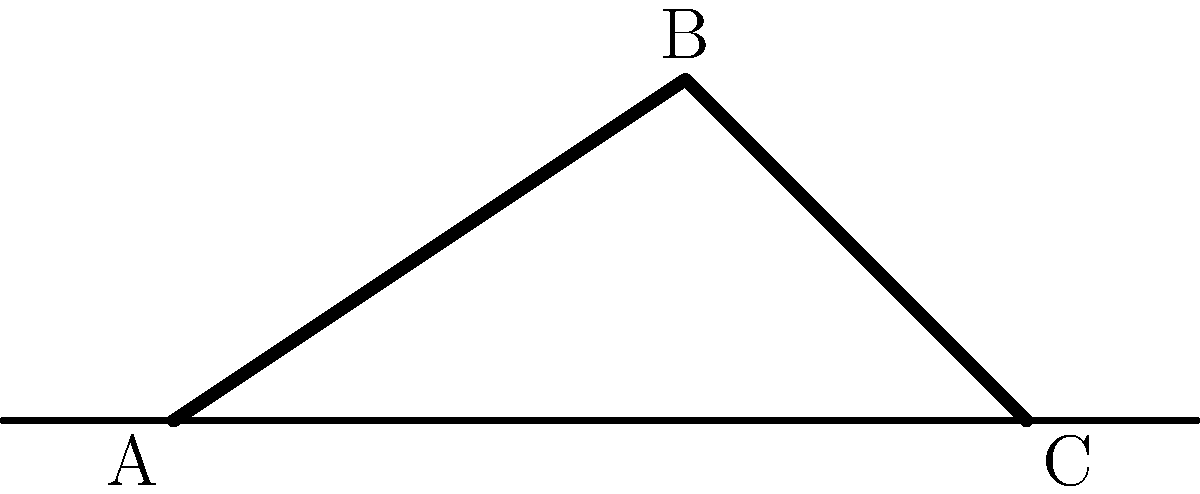During a slide tackle, a SC Telstar player's leg exerts a force F of 800 N at an angle of 45° to the ground. If the distance from the point of force application to the ankle joint (moment arm) is 0.4 m, calculate the magnitude of the torque generated about the ankle. To solve this problem, we'll follow these steps:

1. Recall the formula for torque:
   $$\tau = r \times F \sin(\theta)$$
   where $\tau$ is torque, $r$ is the moment arm, $F$ is the force, and $\theta$ is the angle between the force vector and the moment arm.

2. Identify the given values:
   - Force (F) = 800 N
   - Moment arm (r) = 0.4 m
   - Angle between force and ground = 45°

3. The angle between the force vector and the moment arm is 90° - 45° = 45°. This is because the moment arm is perpendicular to the ground.

4. Substitute the values into the torque equation:
   $$\tau = 0.4 \text{ m} \times 800 \text{ N} \times \sin(45°)$$

5. Calculate $\sin(45°)$:
   $$\sin(45°) = \frac{\sqrt{2}}{2} \approx 0.7071$$

6. Compute the final result:
   $$\tau = 0.4 \times 800 \times 0.7071 = 226.27 \text{ N⋅m}$$

7. Round to two decimal places for the final answer.
Answer: 226.27 N⋅m 